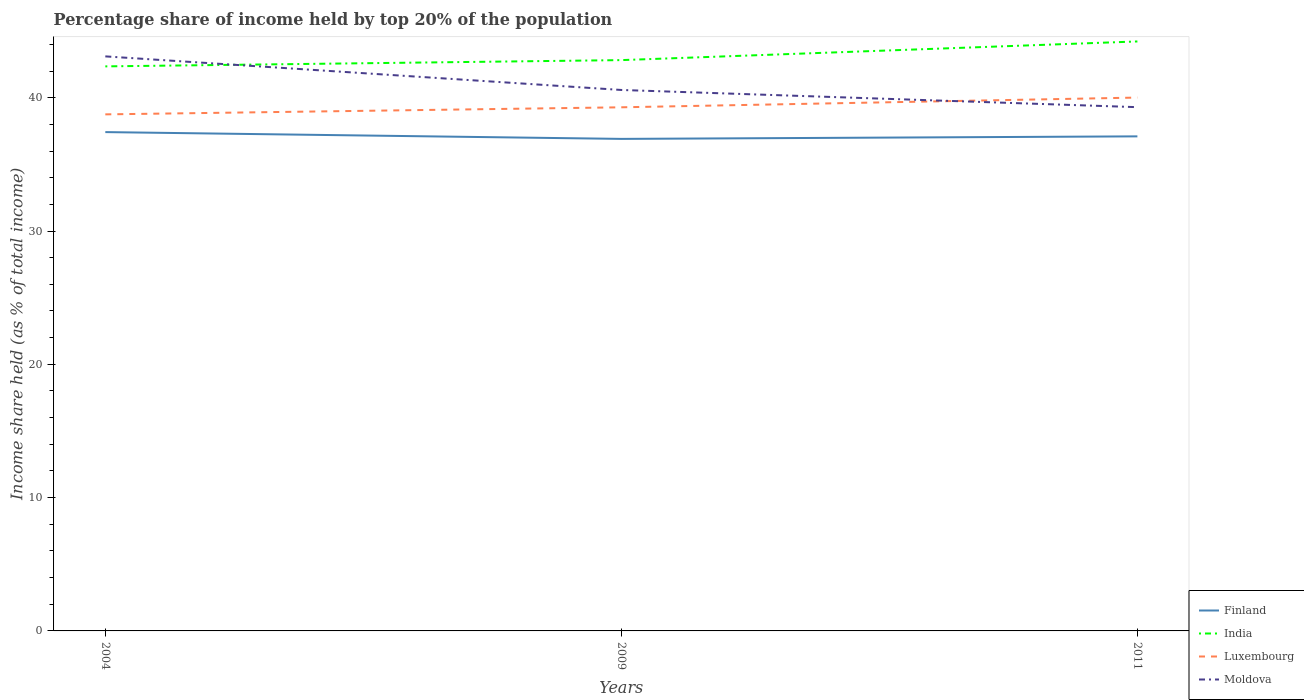Is the number of lines equal to the number of legend labels?
Offer a very short reply. Yes. Across all years, what is the maximum percentage share of income held by top 20% of the population in Moldova?
Your response must be concise. 39.29. What is the total percentage share of income held by top 20% of the population in India in the graph?
Offer a terse response. -0.47. What is the difference between the highest and the second highest percentage share of income held by top 20% of the population in Luxembourg?
Your answer should be compact. 1.26. How many lines are there?
Provide a short and direct response. 4. Does the graph contain any zero values?
Offer a very short reply. No. How many legend labels are there?
Keep it short and to the point. 4. What is the title of the graph?
Your response must be concise. Percentage share of income held by top 20% of the population. What is the label or title of the X-axis?
Ensure brevity in your answer.  Years. What is the label or title of the Y-axis?
Offer a terse response. Income share held (as % of total income). What is the Income share held (as % of total income) in Finland in 2004?
Your answer should be compact. 37.42. What is the Income share held (as % of total income) in India in 2004?
Provide a short and direct response. 42.35. What is the Income share held (as % of total income) of Luxembourg in 2004?
Provide a succinct answer. 38.75. What is the Income share held (as % of total income) in Moldova in 2004?
Offer a terse response. 43.1. What is the Income share held (as % of total income) in Finland in 2009?
Provide a short and direct response. 36.91. What is the Income share held (as % of total income) of India in 2009?
Your response must be concise. 42.82. What is the Income share held (as % of total income) of Luxembourg in 2009?
Offer a very short reply. 39.28. What is the Income share held (as % of total income) of Moldova in 2009?
Ensure brevity in your answer.  40.58. What is the Income share held (as % of total income) of Finland in 2011?
Offer a terse response. 37.1. What is the Income share held (as % of total income) in India in 2011?
Provide a short and direct response. 44.22. What is the Income share held (as % of total income) of Luxembourg in 2011?
Your answer should be very brief. 40.01. What is the Income share held (as % of total income) in Moldova in 2011?
Keep it short and to the point. 39.29. Across all years, what is the maximum Income share held (as % of total income) of Finland?
Offer a terse response. 37.42. Across all years, what is the maximum Income share held (as % of total income) of India?
Keep it short and to the point. 44.22. Across all years, what is the maximum Income share held (as % of total income) in Luxembourg?
Your answer should be very brief. 40.01. Across all years, what is the maximum Income share held (as % of total income) of Moldova?
Offer a terse response. 43.1. Across all years, what is the minimum Income share held (as % of total income) of Finland?
Make the answer very short. 36.91. Across all years, what is the minimum Income share held (as % of total income) in India?
Your answer should be very brief. 42.35. Across all years, what is the minimum Income share held (as % of total income) in Luxembourg?
Give a very brief answer. 38.75. Across all years, what is the minimum Income share held (as % of total income) of Moldova?
Give a very brief answer. 39.29. What is the total Income share held (as % of total income) in Finland in the graph?
Make the answer very short. 111.43. What is the total Income share held (as % of total income) in India in the graph?
Make the answer very short. 129.39. What is the total Income share held (as % of total income) of Luxembourg in the graph?
Provide a succinct answer. 118.04. What is the total Income share held (as % of total income) of Moldova in the graph?
Ensure brevity in your answer.  122.97. What is the difference between the Income share held (as % of total income) of Finland in 2004 and that in 2009?
Your response must be concise. 0.51. What is the difference between the Income share held (as % of total income) in India in 2004 and that in 2009?
Provide a short and direct response. -0.47. What is the difference between the Income share held (as % of total income) of Luxembourg in 2004 and that in 2009?
Offer a terse response. -0.53. What is the difference between the Income share held (as % of total income) of Moldova in 2004 and that in 2009?
Your answer should be very brief. 2.52. What is the difference between the Income share held (as % of total income) of Finland in 2004 and that in 2011?
Offer a very short reply. 0.32. What is the difference between the Income share held (as % of total income) in India in 2004 and that in 2011?
Provide a short and direct response. -1.87. What is the difference between the Income share held (as % of total income) of Luxembourg in 2004 and that in 2011?
Give a very brief answer. -1.26. What is the difference between the Income share held (as % of total income) in Moldova in 2004 and that in 2011?
Give a very brief answer. 3.81. What is the difference between the Income share held (as % of total income) in Finland in 2009 and that in 2011?
Give a very brief answer. -0.19. What is the difference between the Income share held (as % of total income) of India in 2009 and that in 2011?
Keep it short and to the point. -1.4. What is the difference between the Income share held (as % of total income) of Luxembourg in 2009 and that in 2011?
Give a very brief answer. -0.73. What is the difference between the Income share held (as % of total income) in Moldova in 2009 and that in 2011?
Offer a very short reply. 1.29. What is the difference between the Income share held (as % of total income) of Finland in 2004 and the Income share held (as % of total income) of India in 2009?
Ensure brevity in your answer.  -5.4. What is the difference between the Income share held (as % of total income) in Finland in 2004 and the Income share held (as % of total income) in Luxembourg in 2009?
Your answer should be compact. -1.86. What is the difference between the Income share held (as % of total income) of Finland in 2004 and the Income share held (as % of total income) of Moldova in 2009?
Offer a very short reply. -3.16. What is the difference between the Income share held (as % of total income) of India in 2004 and the Income share held (as % of total income) of Luxembourg in 2009?
Provide a succinct answer. 3.07. What is the difference between the Income share held (as % of total income) in India in 2004 and the Income share held (as % of total income) in Moldova in 2009?
Offer a terse response. 1.77. What is the difference between the Income share held (as % of total income) of Luxembourg in 2004 and the Income share held (as % of total income) of Moldova in 2009?
Provide a succinct answer. -1.83. What is the difference between the Income share held (as % of total income) of Finland in 2004 and the Income share held (as % of total income) of India in 2011?
Your answer should be very brief. -6.8. What is the difference between the Income share held (as % of total income) in Finland in 2004 and the Income share held (as % of total income) in Luxembourg in 2011?
Keep it short and to the point. -2.59. What is the difference between the Income share held (as % of total income) in Finland in 2004 and the Income share held (as % of total income) in Moldova in 2011?
Make the answer very short. -1.87. What is the difference between the Income share held (as % of total income) in India in 2004 and the Income share held (as % of total income) in Luxembourg in 2011?
Your answer should be very brief. 2.34. What is the difference between the Income share held (as % of total income) of India in 2004 and the Income share held (as % of total income) of Moldova in 2011?
Offer a terse response. 3.06. What is the difference between the Income share held (as % of total income) in Luxembourg in 2004 and the Income share held (as % of total income) in Moldova in 2011?
Provide a succinct answer. -0.54. What is the difference between the Income share held (as % of total income) in Finland in 2009 and the Income share held (as % of total income) in India in 2011?
Keep it short and to the point. -7.31. What is the difference between the Income share held (as % of total income) of Finland in 2009 and the Income share held (as % of total income) of Luxembourg in 2011?
Your answer should be compact. -3.1. What is the difference between the Income share held (as % of total income) in Finland in 2009 and the Income share held (as % of total income) in Moldova in 2011?
Give a very brief answer. -2.38. What is the difference between the Income share held (as % of total income) in India in 2009 and the Income share held (as % of total income) in Luxembourg in 2011?
Ensure brevity in your answer.  2.81. What is the difference between the Income share held (as % of total income) in India in 2009 and the Income share held (as % of total income) in Moldova in 2011?
Offer a terse response. 3.53. What is the difference between the Income share held (as % of total income) in Luxembourg in 2009 and the Income share held (as % of total income) in Moldova in 2011?
Your answer should be compact. -0.01. What is the average Income share held (as % of total income) in Finland per year?
Ensure brevity in your answer.  37.14. What is the average Income share held (as % of total income) of India per year?
Offer a terse response. 43.13. What is the average Income share held (as % of total income) in Luxembourg per year?
Your response must be concise. 39.35. What is the average Income share held (as % of total income) in Moldova per year?
Provide a short and direct response. 40.99. In the year 2004, what is the difference between the Income share held (as % of total income) in Finland and Income share held (as % of total income) in India?
Your answer should be compact. -4.93. In the year 2004, what is the difference between the Income share held (as % of total income) in Finland and Income share held (as % of total income) in Luxembourg?
Give a very brief answer. -1.33. In the year 2004, what is the difference between the Income share held (as % of total income) of Finland and Income share held (as % of total income) of Moldova?
Your response must be concise. -5.68. In the year 2004, what is the difference between the Income share held (as % of total income) in India and Income share held (as % of total income) in Luxembourg?
Offer a terse response. 3.6. In the year 2004, what is the difference between the Income share held (as % of total income) in India and Income share held (as % of total income) in Moldova?
Offer a terse response. -0.75. In the year 2004, what is the difference between the Income share held (as % of total income) in Luxembourg and Income share held (as % of total income) in Moldova?
Your answer should be compact. -4.35. In the year 2009, what is the difference between the Income share held (as % of total income) in Finland and Income share held (as % of total income) in India?
Offer a very short reply. -5.91. In the year 2009, what is the difference between the Income share held (as % of total income) of Finland and Income share held (as % of total income) of Luxembourg?
Keep it short and to the point. -2.37. In the year 2009, what is the difference between the Income share held (as % of total income) of Finland and Income share held (as % of total income) of Moldova?
Offer a very short reply. -3.67. In the year 2009, what is the difference between the Income share held (as % of total income) in India and Income share held (as % of total income) in Luxembourg?
Your response must be concise. 3.54. In the year 2009, what is the difference between the Income share held (as % of total income) of India and Income share held (as % of total income) of Moldova?
Provide a short and direct response. 2.24. In the year 2009, what is the difference between the Income share held (as % of total income) in Luxembourg and Income share held (as % of total income) in Moldova?
Ensure brevity in your answer.  -1.3. In the year 2011, what is the difference between the Income share held (as % of total income) of Finland and Income share held (as % of total income) of India?
Provide a succinct answer. -7.12. In the year 2011, what is the difference between the Income share held (as % of total income) in Finland and Income share held (as % of total income) in Luxembourg?
Provide a succinct answer. -2.91. In the year 2011, what is the difference between the Income share held (as % of total income) of Finland and Income share held (as % of total income) of Moldova?
Give a very brief answer. -2.19. In the year 2011, what is the difference between the Income share held (as % of total income) of India and Income share held (as % of total income) of Luxembourg?
Provide a succinct answer. 4.21. In the year 2011, what is the difference between the Income share held (as % of total income) of India and Income share held (as % of total income) of Moldova?
Keep it short and to the point. 4.93. In the year 2011, what is the difference between the Income share held (as % of total income) in Luxembourg and Income share held (as % of total income) in Moldova?
Your answer should be very brief. 0.72. What is the ratio of the Income share held (as % of total income) in Finland in 2004 to that in 2009?
Offer a terse response. 1.01. What is the ratio of the Income share held (as % of total income) in Luxembourg in 2004 to that in 2009?
Keep it short and to the point. 0.99. What is the ratio of the Income share held (as % of total income) in Moldova in 2004 to that in 2009?
Keep it short and to the point. 1.06. What is the ratio of the Income share held (as % of total income) of Finland in 2004 to that in 2011?
Offer a very short reply. 1.01. What is the ratio of the Income share held (as % of total income) of India in 2004 to that in 2011?
Keep it short and to the point. 0.96. What is the ratio of the Income share held (as % of total income) of Luxembourg in 2004 to that in 2011?
Provide a short and direct response. 0.97. What is the ratio of the Income share held (as % of total income) in Moldova in 2004 to that in 2011?
Offer a very short reply. 1.1. What is the ratio of the Income share held (as % of total income) in India in 2009 to that in 2011?
Give a very brief answer. 0.97. What is the ratio of the Income share held (as % of total income) of Luxembourg in 2009 to that in 2011?
Make the answer very short. 0.98. What is the ratio of the Income share held (as % of total income) of Moldova in 2009 to that in 2011?
Give a very brief answer. 1.03. What is the difference between the highest and the second highest Income share held (as % of total income) in Finland?
Your answer should be very brief. 0.32. What is the difference between the highest and the second highest Income share held (as % of total income) in Luxembourg?
Offer a terse response. 0.73. What is the difference between the highest and the second highest Income share held (as % of total income) in Moldova?
Ensure brevity in your answer.  2.52. What is the difference between the highest and the lowest Income share held (as % of total income) in Finland?
Offer a very short reply. 0.51. What is the difference between the highest and the lowest Income share held (as % of total income) of India?
Your answer should be compact. 1.87. What is the difference between the highest and the lowest Income share held (as % of total income) of Luxembourg?
Keep it short and to the point. 1.26. What is the difference between the highest and the lowest Income share held (as % of total income) in Moldova?
Offer a very short reply. 3.81. 